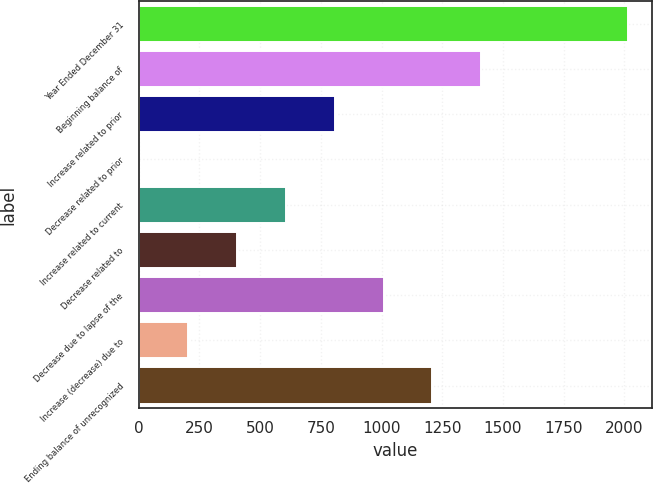Convert chart. <chart><loc_0><loc_0><loc_500><loc_500><bar_chart><fcel>Year Ended December 31<fcel>Beginning balance of<fcel>Increase related to prior<fcel>Decrease related to prior<fcel>Increase related to current<fcel>Decrease related to<fcel>Decrease due to lapse of the<fcel>Increase (decrease) due to<fcel>Ending balance of unrecognized<nl><fcel>2014<fcel>1410.4<fcel>806.8<fcel>2<fcel>605.6<fcel>404.4<fcel>1008<fcel>203.2<fcel>1209.2<nl></chart> 